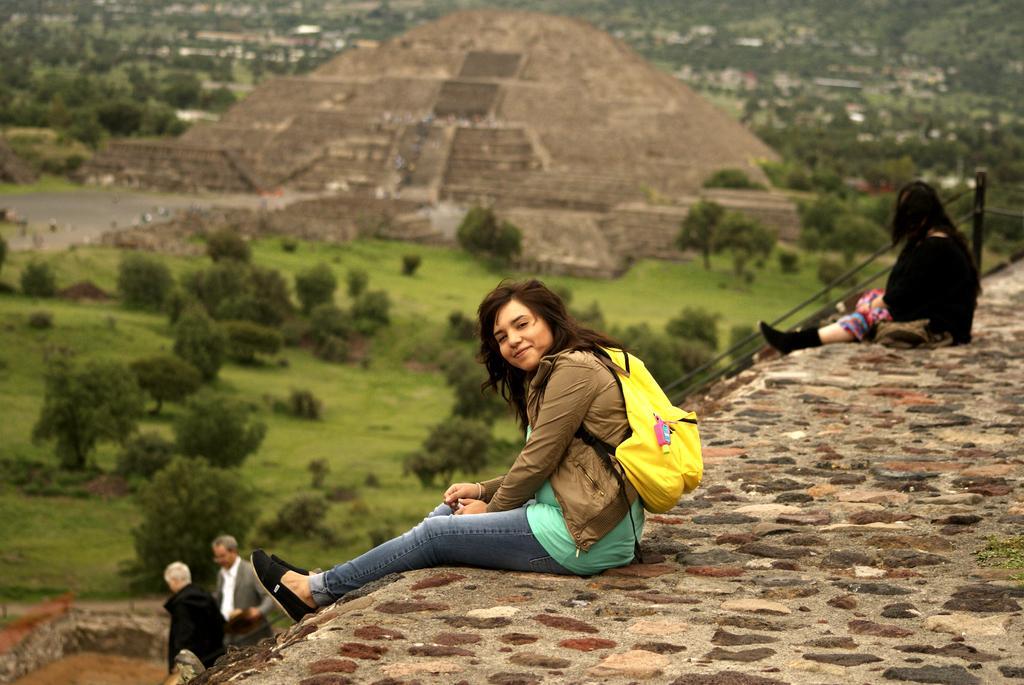How would you summarize this image in a sentence or two? In this image we can see two women sitting on a wall. We can also see some metal poles, two men, a group of trees, grass, an architecture and some buildings. 